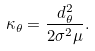Convert formula to latex. <formula><loc_0><loc_0><loc_500><loc_500>\kappa _ { \theta } = \frac { d _ { \theta } ^ { 2 } } { 2 \sigma ^ { 2 } \mu } .</formula> 